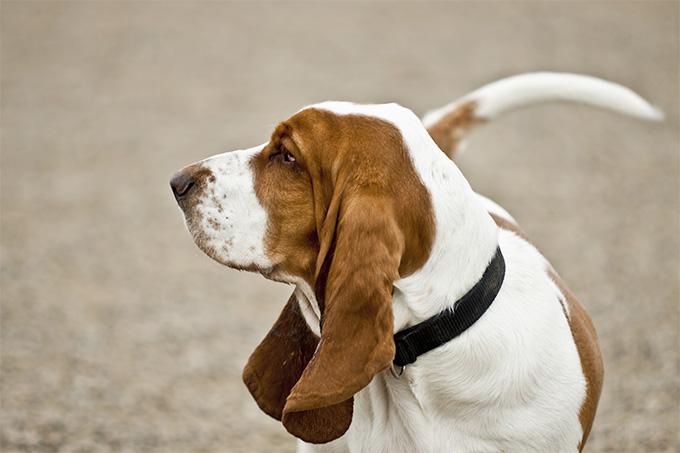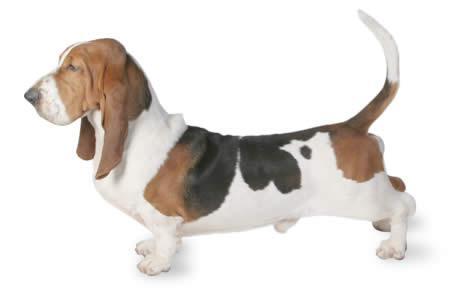The first image is the image on the left, the second image is the image on the right. For the images shown, is this caption "The mouth of the dog in the image on the left is open." true? Answer yes or no. No. The first image is the image on the left, the second image is the image on the right. Evaluate the accuracy of this statement regarding the images: "An image shows one forward-turned basset hound, which has its mouth open fairly wide.". Is it true? Answer yes or no. No. 